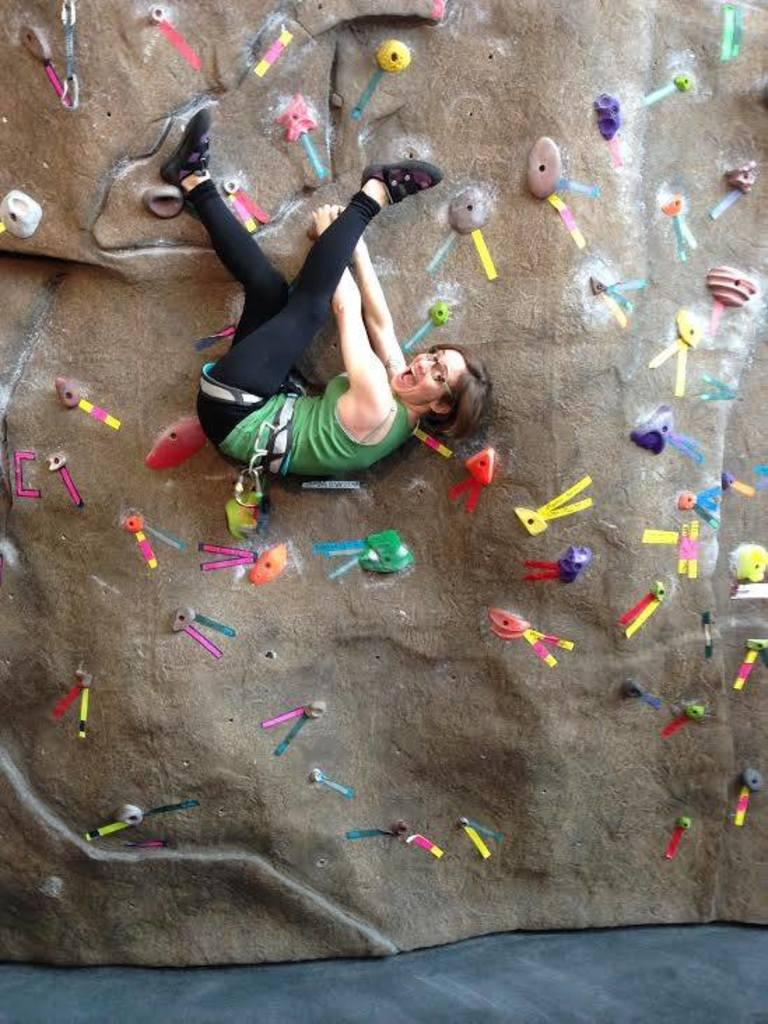What is the person in the image doing? The person is climbing the wall in the image. What can be seen on the wall besides the person? There are objects on the wall in the image. When was the person in the image born? The provided facts do not mention the person's birth, so it cannot be determined from the image. 